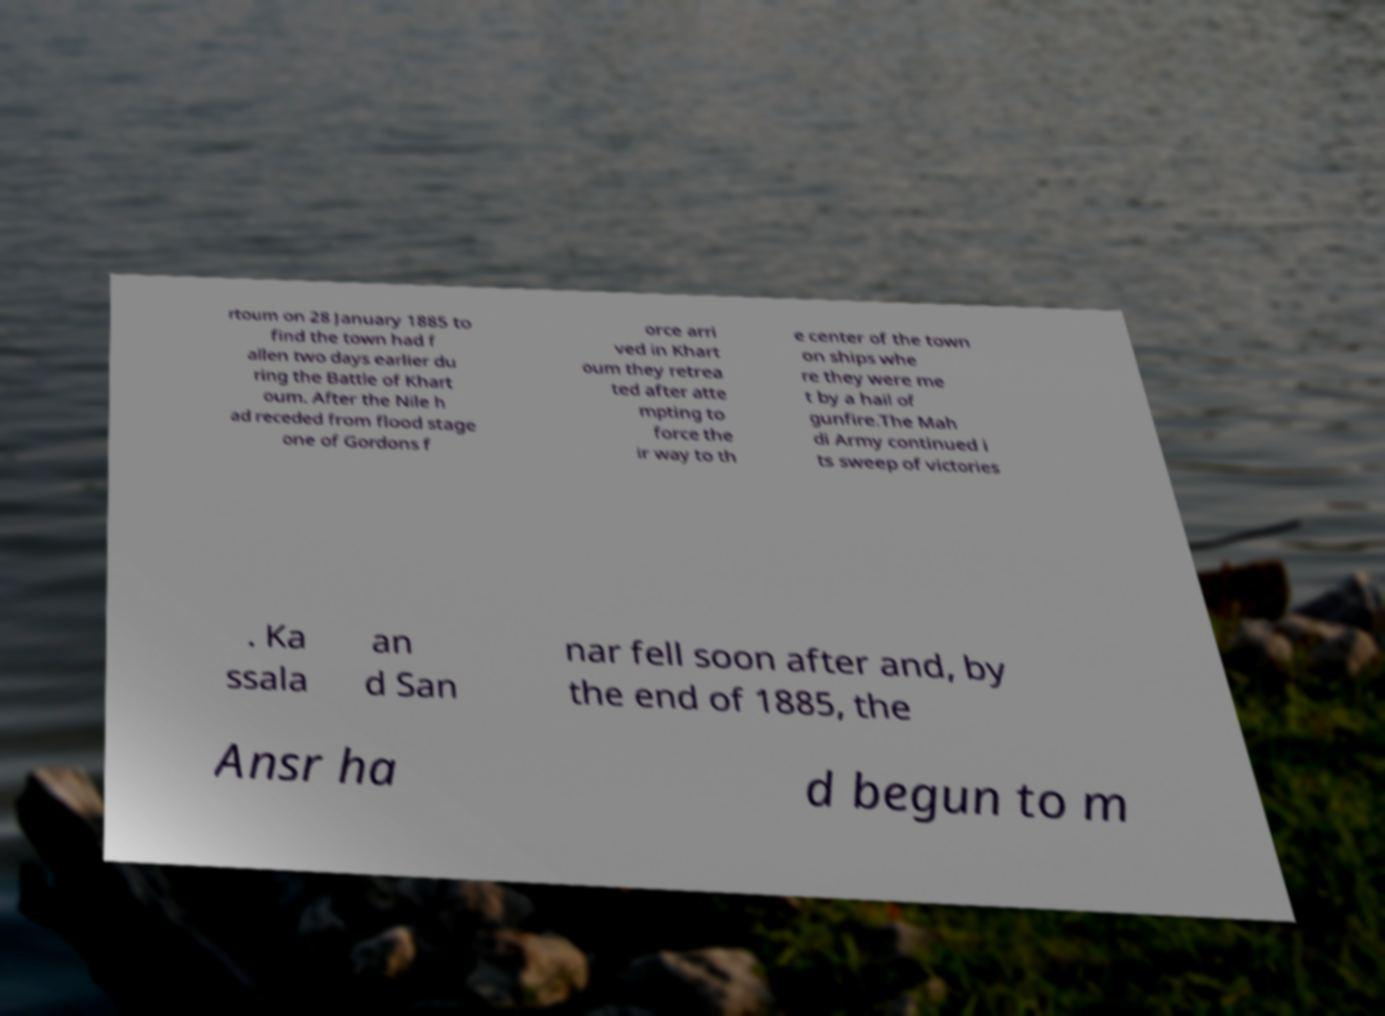I need the written content from this picture converted into text. Can you do that? rtoum on 28 January 1885 to find the town had f allen two days earlier du ring the Battle of Khart oum. After the Nile h ad receded from flood stage one of Gordons f orce arri ved in Khart oum they retrea ted after atte mpting to force the ir way to th e center of the town on ships whe re they were me t by a hail of gunfire.The Mah di Army continued i ts sweep of victories . Ka ssala an d San nar fell soon after and, by the end of 1885, the Ansr ha d begun to m 